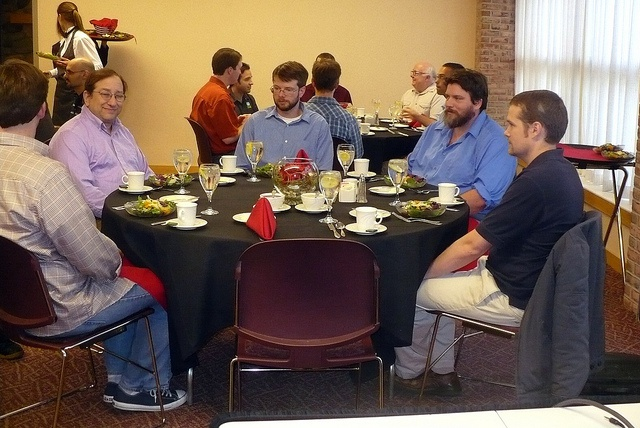Describe the objects in this image and their specific colors. I can see people in black, gray, darkgray, and navy tones, people in black, gray, and tan tones, dining table in black, gray, and beige tones, chair in black, maroon, and brown tones, and chair in black and gray tones in this image. 